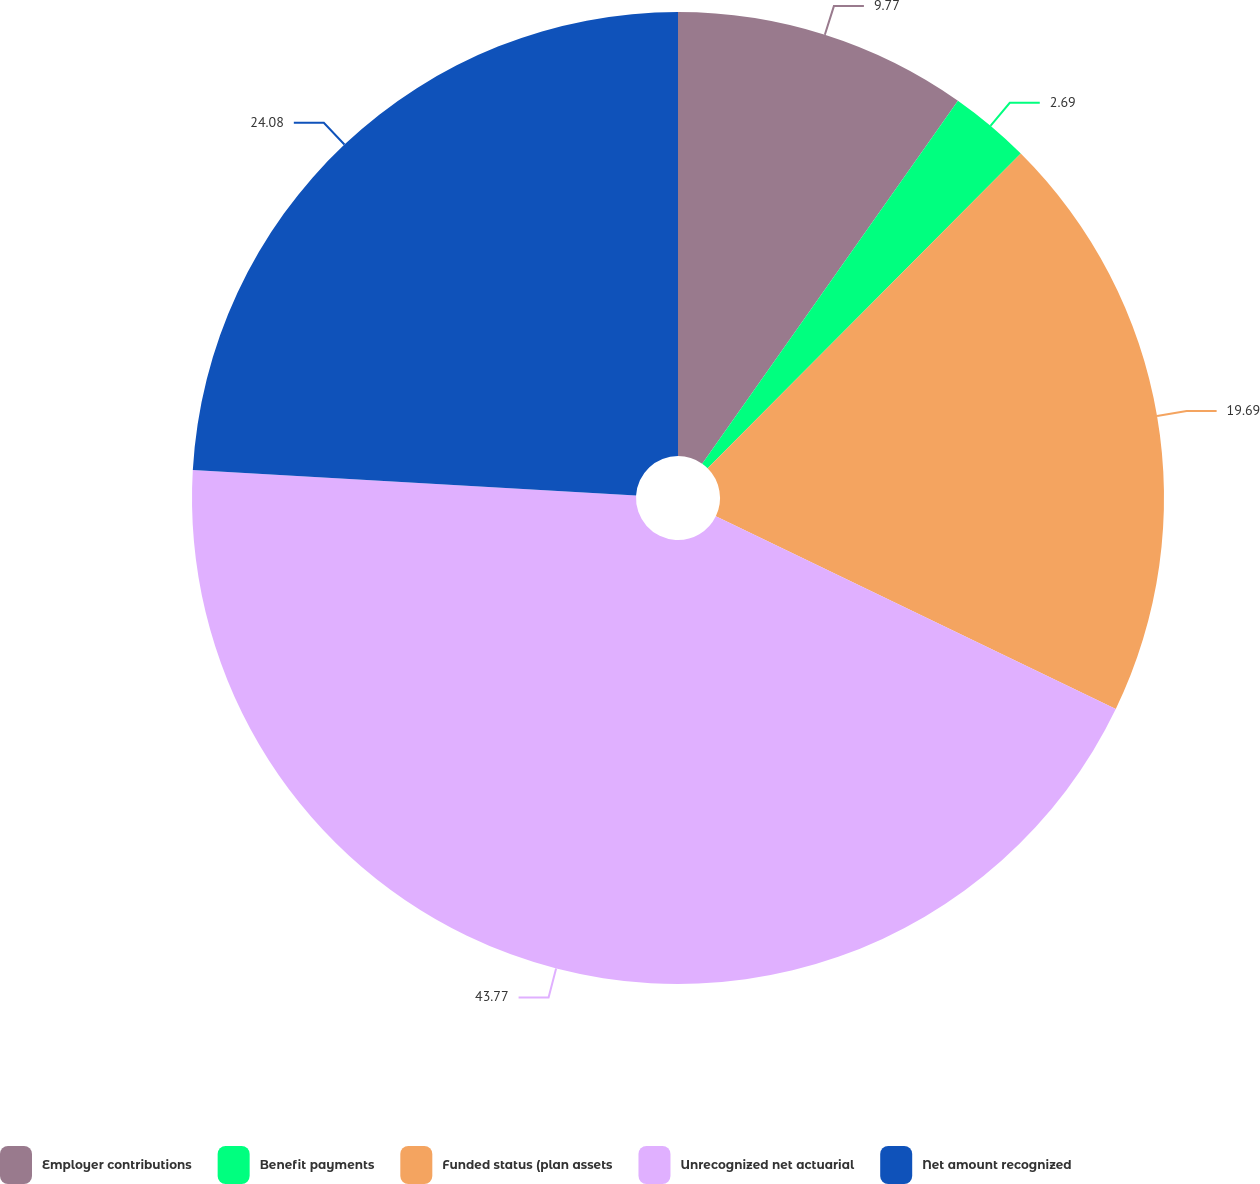<chart> <loc_0><loc_0><loc_500><loc_500><pie_chart><fcel>Employer contributions<fcel>Benefit payments<fcel>Funded status (plan assets<fcel>Unrecognized net actuarial<fcel>Net amount recognized<nl><fcel>9.77%<fcel>2.69%<fcel>19.69%<fcel>43.77%<fcel>24.08%<nl></chart> 